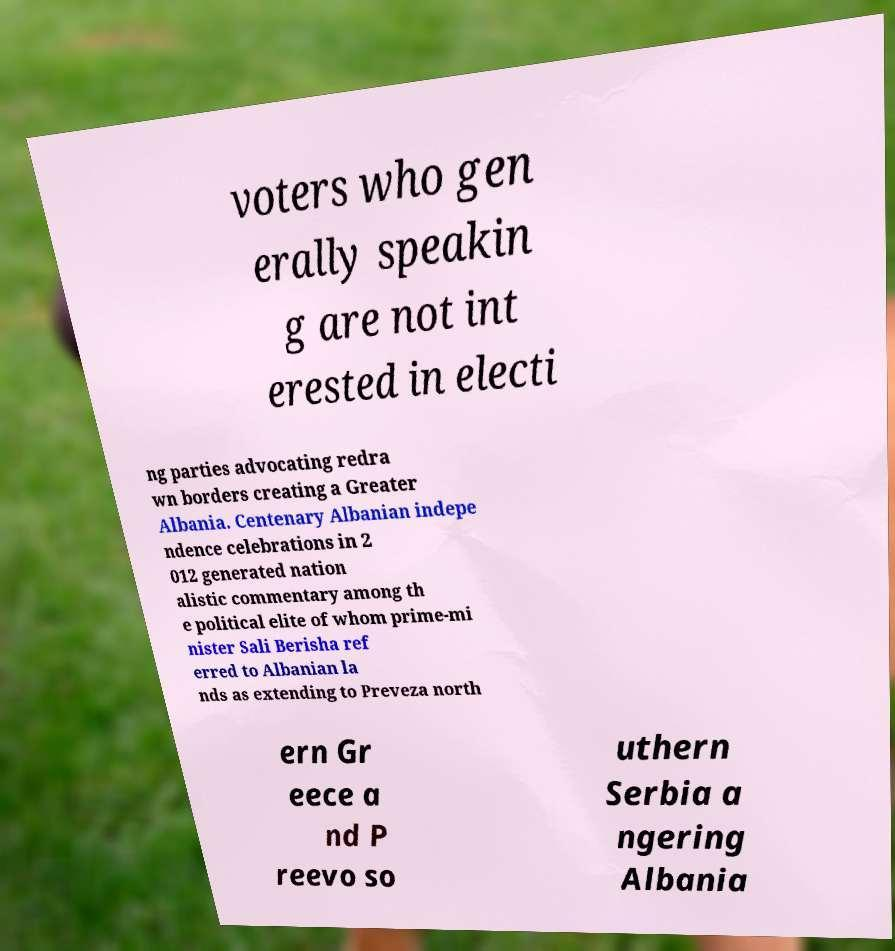Can you accurately transcribe the text from the provided image for me? voters who gen erally speakin g are not int erested in electi ng parties advocating redra wn borders creating a Greater Albania. Centenary Albanian indepe ndence celebrations in 2 012 generated nation alistic commentary among th e political elite of whom prime-mi nister Sali Berisha ref erred to Albanian la nds as extending to Preveza north ern Gr eece a nd P reevo so uthern Serbia a ngering Albania 